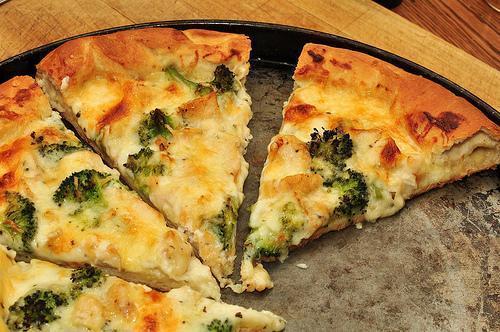How many pizza slices are there?
Give a very brief answer. 4. 